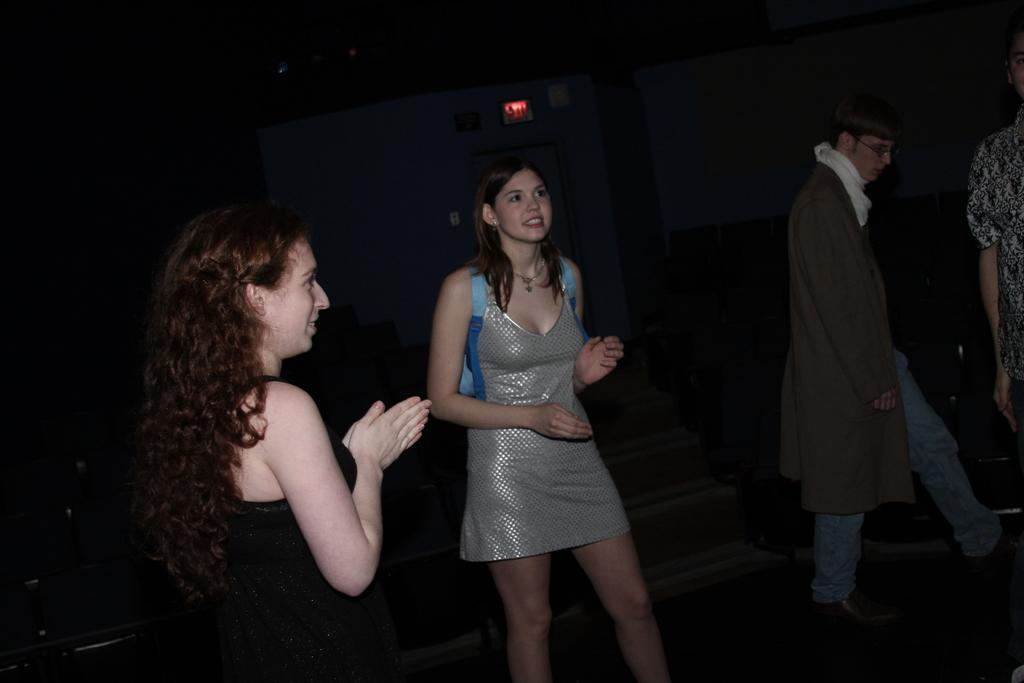How many people are in the image? There is a group of people in the image. What are the people in the image doing? The people are standing and smiling. What can be observed about the background of the image? The background of the image is dark. What type of flag is being waved by the people in the image? There is no flag present in the image; the people are simply standing and smiling. 